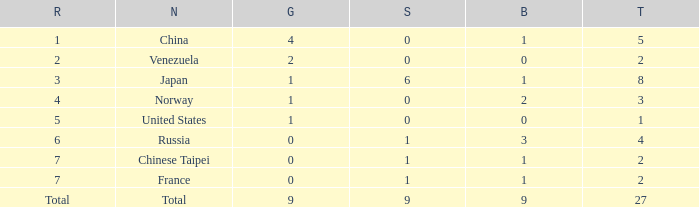Parse the full table. {'header': ['R', 'N', 'G', 'S', 'B', 'T'], 'rows': [['1', 'China', '4', '0', '1', '5'], ['2', 'Venezuela', '2', '0', '0', '2'], ['3', 'Japan', '1', '6', '1', '8'], ['4', 'Norway', '1', '0', '2', '3'], ['5', 'United States', '1', '0', '0', '1'], ['6', 'Russia', '0', '1', '3', '4'], ['7', 'Chinese Taipei', '0', '1', '1', '2'], ['7', 'France', '0', '1', '1', '2'], ['Total', 'Total', '9', '9', '9', '27']]} What is the average Bronze for rank 3 and total is more than 8? None. 